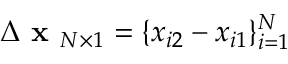<formula> <loc_0><loc_0><loc_500><loc_500>\Delta x _ { N \times 1 } = \{ x _ { i 2 } - x _ { i 1 } \} _ { i = 1 } ^ { N }</formula> 